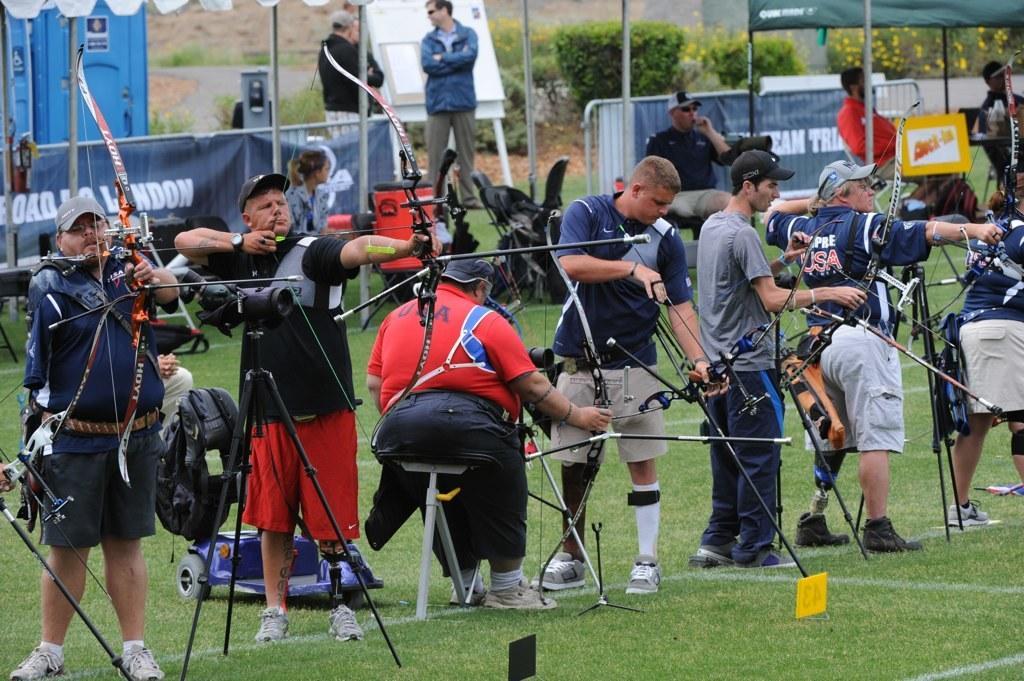Could you give a brief overview of what you see in this image? This picture is clicked outside. In the center we can see the group of people standing on the ground and playing archery and there are some items placed on the ground. In the background we can see a tent, group of people, banners on which the text is printed and some other objects and plants. 